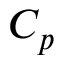Convert formula to latex. <formula><loc_0><loc_0><loc_500><loc_500>C _ { p }</formula> 